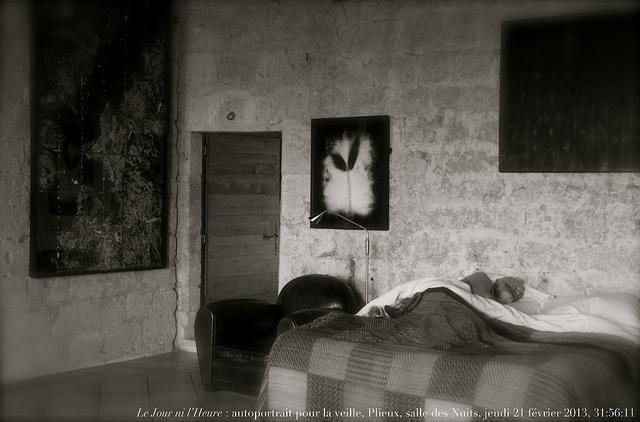How many pictures are hanging in the room?
Give a very brief answer. 3. 